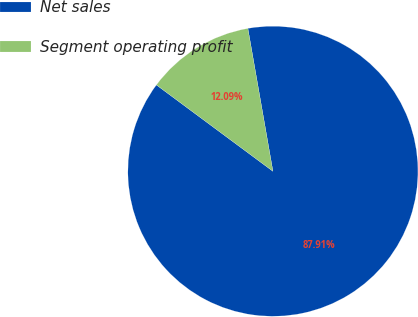Convert chart. <chart><loc_0><loc_0><loc_500><loc_500><pie_chart><fcel>Net sales<fcel>Segment operating profit<nl><fcel>87.91%<fcel>12.09%<nl></chart> 